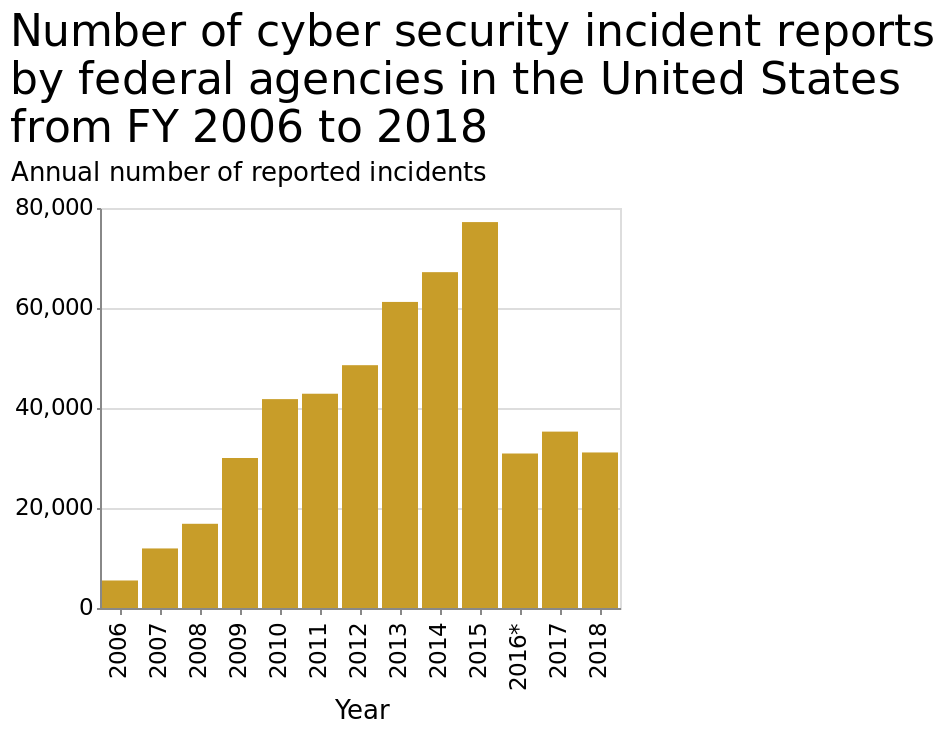<image>
What does the x-axis represent on the chart?  The x-axis represents the years from 2006 to 2018 on a linear scale. What happened to the number of cyber security incidents after 2015? The number of cyber security incidents dropped after 2015. What does the y-axis represent? The y-axis represents the annual number of reported cyber security incidents. 